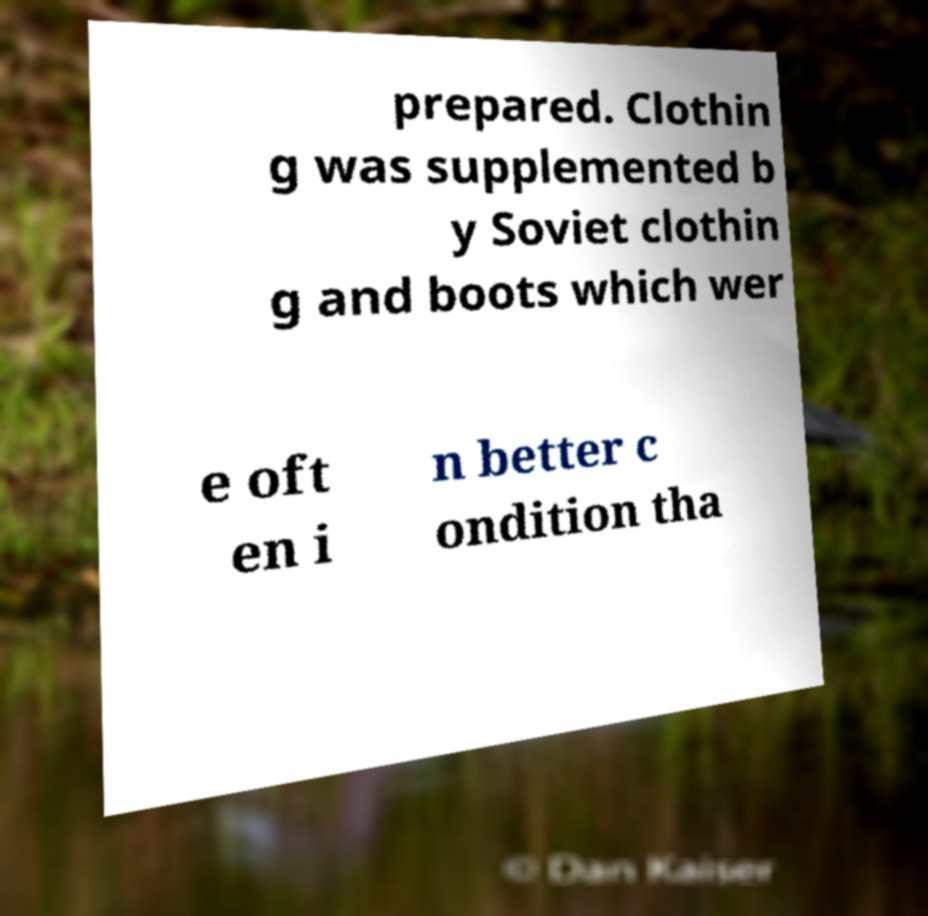I need the written content from this picture converted into text. Can you do that? prepared. Clothin g was supplemented b y Soviet clothin g and boots which wer e oft en i n better c ondition tha 